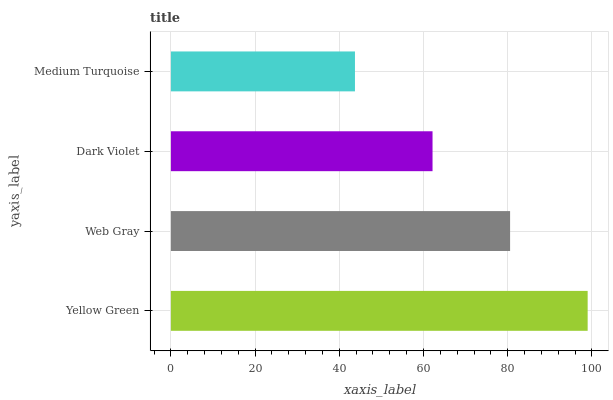Is Medium Turquoise the minimum?
Answer yes or no. Yes. Is Yellow Green the maximum?
Answer yes or no. Yes. Is Web Gray the minimum?
Answer yes or no. No. Is Web Gray the maximum?
Answer yes or no. No. Is Yellow Green greater than Web Gray?
Answer yes or no. Yes. Is Web Gray less than Yellow Green?
Answer yes or no. Yes. Is Web Gray greater than Yellow Green?
Answer yes or no. No. Is Yellow Green less than Web Gray?
Answer yes or no. No. Is Web Gray the high median?
Answer yes or no. Yes. Is Dark Violet the low median?
Answer yes or no. Yes. Is Yellow Green the high median?
Answer yes or no. No. Is Web Gray the low median?
Answer yes or no. No. 